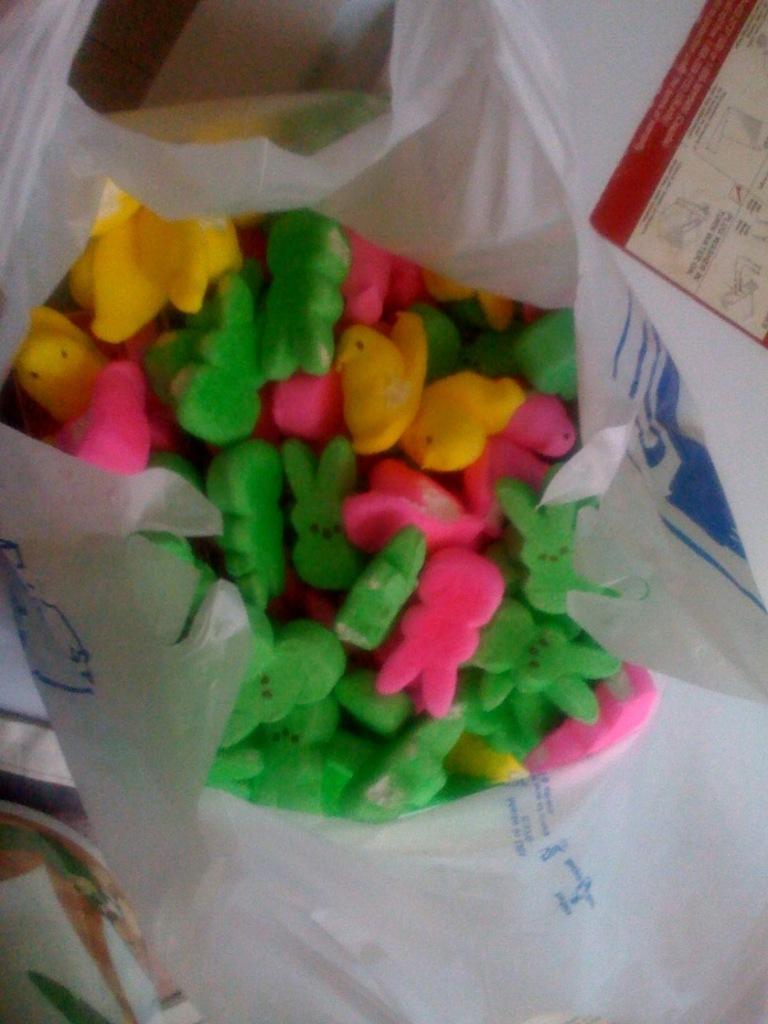In one or two sentences, can you explain what this image depicts? In this Picture we can see a polythene cover in which there are multi colors of erasers in green , yellow and pink in colour. 